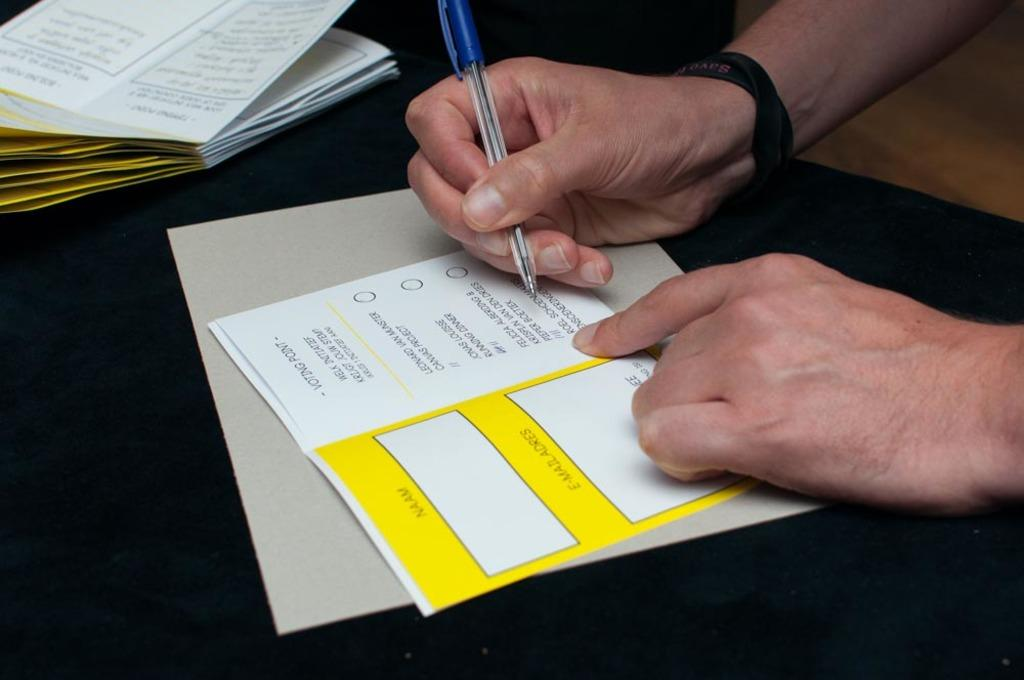<image>
Offer a succinct explanation of the picture presented. A person is filling out a voting form with a pen. 